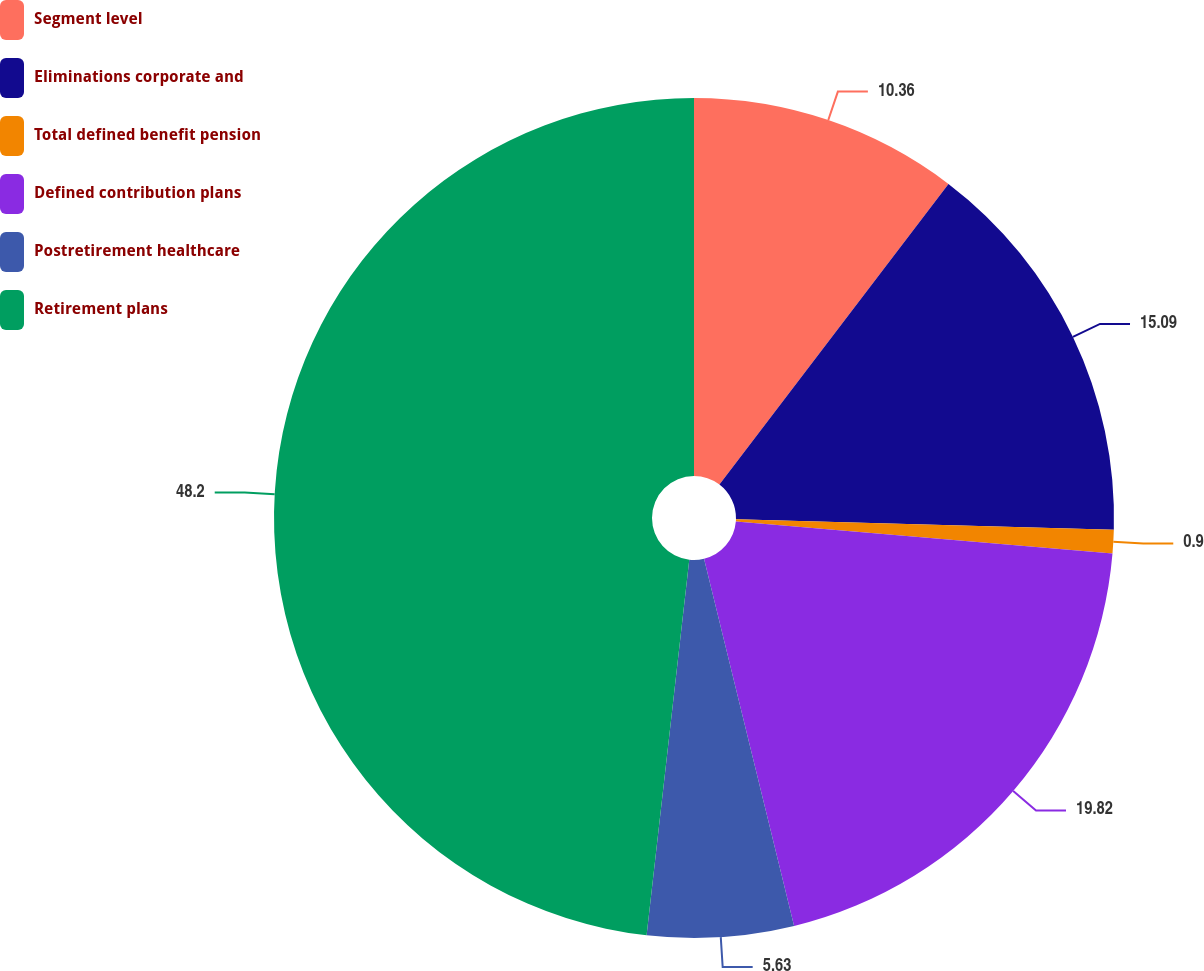<chart> <loc_0><loc_0><loc_500><loc_500><pie_chart><fcel>Segment level<fcel>Eliminations corporate and<fcel>Total defined benefit pension<fcel>Defined contribution plans<fcel>Postretirement healthcare<fcel>Retirement plans<nl><fcel>10.36%<fcel>15.09%<fcel>0.9%<fcel>19.82%<fcel>5.63%<fcel>48.2%<nl></chart> 